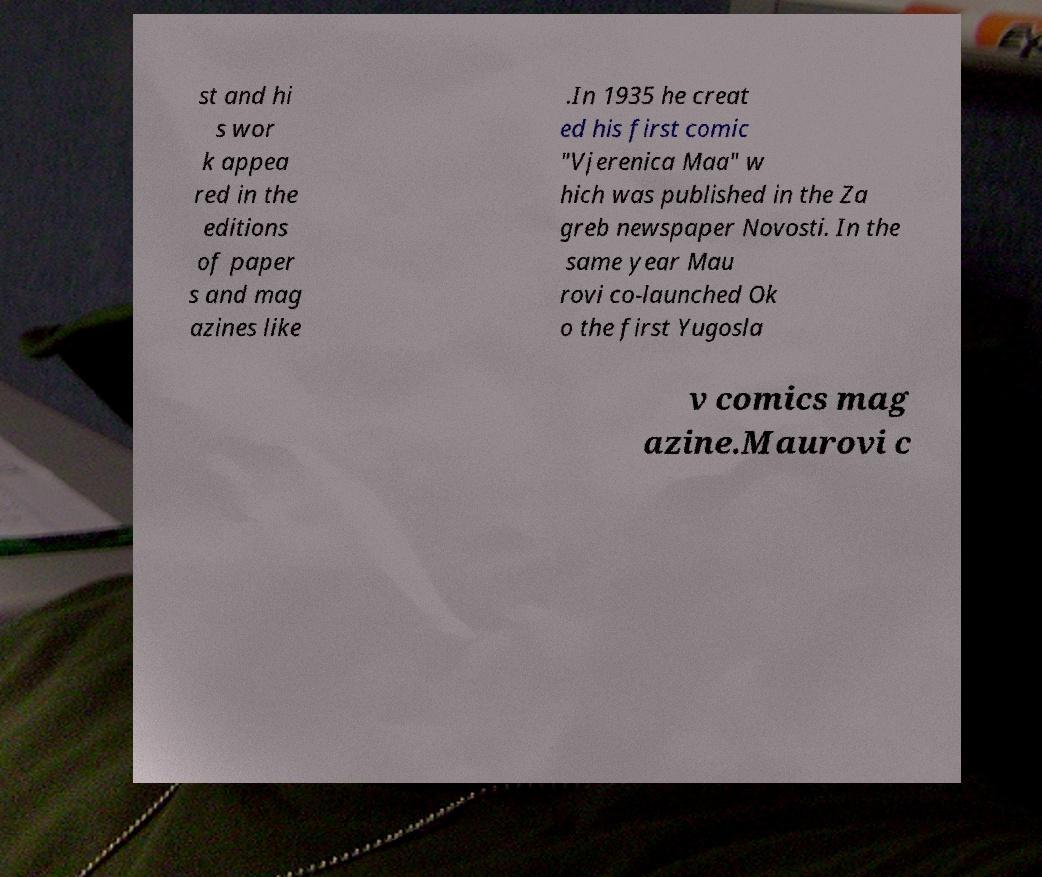Can you read and provide the text displayed in the image?This photo seems to have some interesting text. Can you extract and type it out for me? st and hi s wor k appea red in the editions of paper s and mag azines like .In 1935 he creat ed his first comic "Vjerenica Maa" w hich was published in the Za greb newspaper Novosti. In the same year Mau rovi co-launched Ok o the first Yugosla v comics mag azine.Maurovi c 